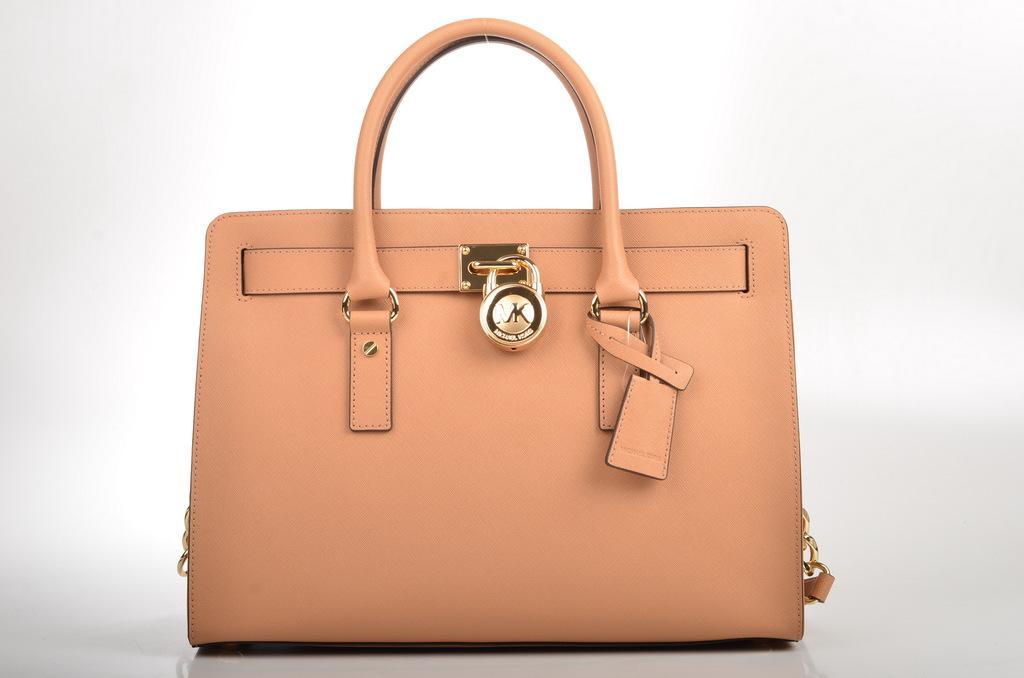Could you give a brief overview of what you see in this image? There is a beautiful brown bag in this picture which is named as CK. 